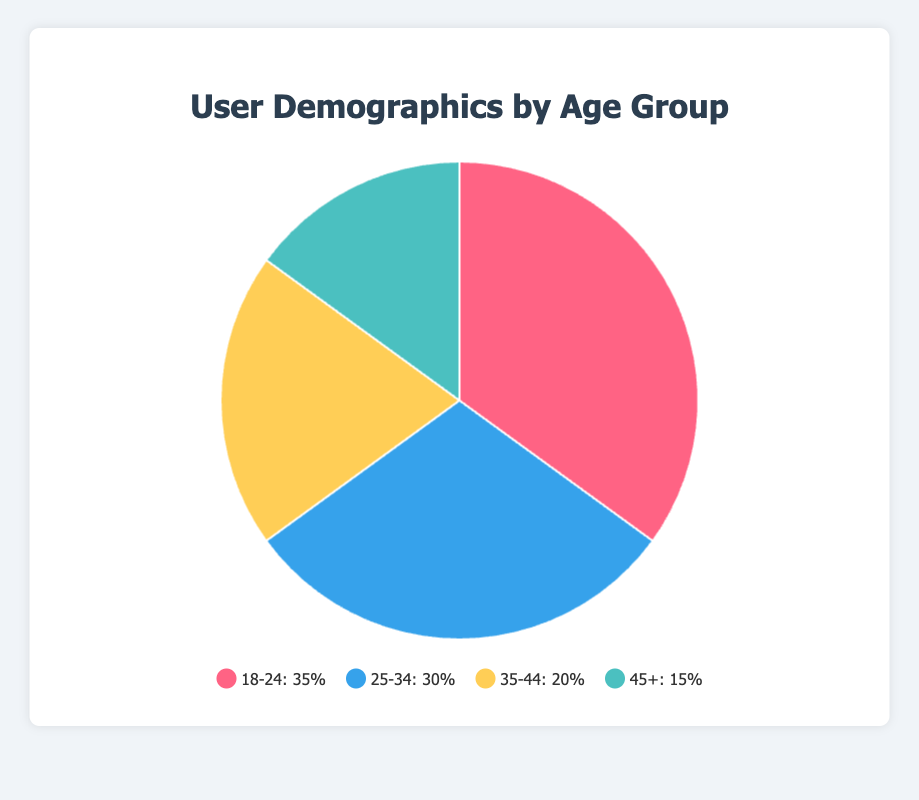What age group has the highest percentage of users? From the Pie Chart, the largest section is represented by the age group 18-24, which is labeled as 35%. Therefore, the age group with the highest percentage of users is 18-24.
Answer: 18-24 Which age group has the smallest percentage of users? The smallest section of the pie chart is labeled as 45+ with 15%, indicating that this age group has the smallest percentage of users.
Answer: 45+ What is the total percentage of users aged 25-34 and 45+? The percentage for the age group 25-34 is 30% and for the age group 45+ is 15%. Adding these together: 30% + 15% = 45%.
Answer: 45% How does the percentage of users aged 35-44 compare to those aged 25-34? Users aged 35-44 make up 20% of the pie chart, while those aged 25-34 make up 30%. Hence, the percentage of users aged 25-34 is higher than those aged 35-44 by 10%.
Answer: 25-34 has 10% more Which age group is represented by the blue section of the pie chart? Referring to the legend, the blue color represents the age group 25-34.
Answer: 25-34 What's the difference in percentage between users aged 18-24 and users aged 45+? The percentage of users aged 18-24 is 35% and that of users aged 45+ is 15%. The difference is 35% - 15% = 20%.
Answer: 20% What percentage of users are aged 35-44? By glancing at the pie chart's labels, the age group 35-44 is marked as 20%.
Answer: 20% If a user falls into the 35-44 age group, what is the likelihood that they use productivity tools over travel apps? The pie chart data specify that within the 35-44 age group, 40% use productivity tools and 20% use travel apps. Therefore, they are twice as likely to use productivity tools as compared to travel apps.
Answer: Twice as likely Calculate the average percentage of users across all age groups. The percentages for the age groups are: 35%, 30%, 20%, and 15%. The average is calculated as (35 + 30 + 20 + 15) / 4 = 25%.
Answer: 25% Which age group is represented by the yellow section of the pie chart? Referring to the legend, the yellow color represents the age group 35-44.
Answer: 35-44 Calculate the combined percentage of users aged 18-24 and 35-44. Adding the percentages for the age groups 18-24 (35%) and 35-44 (20%) gives: 35% + 20% = 55%.
Answer: 55% 